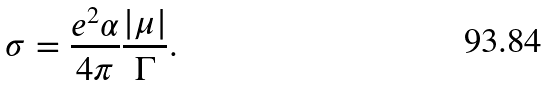Convert formula to latex. <formula><loc_0><loc_0><loc_500><loc_500>\sigma = \frac { e ^ { 2 } \alpha } { 4 \pi } \frac { | \mu | } { \Gamma } .</formula> 